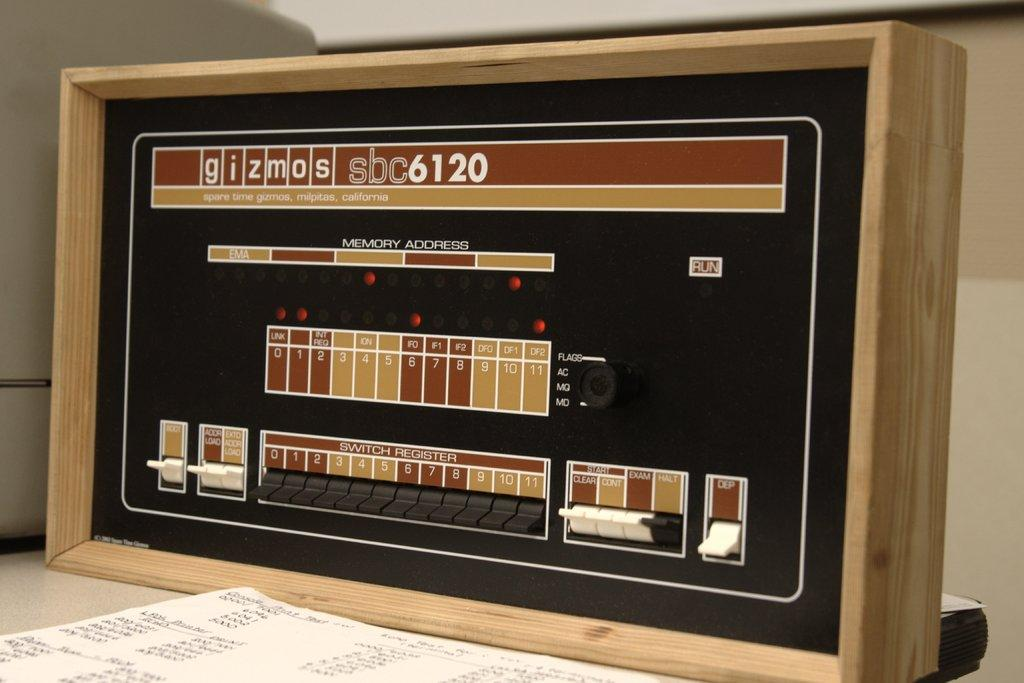Provide a one-sentence caption for the provided image. A panel with switches ad numbers by Gizmos has a retro look to it. 